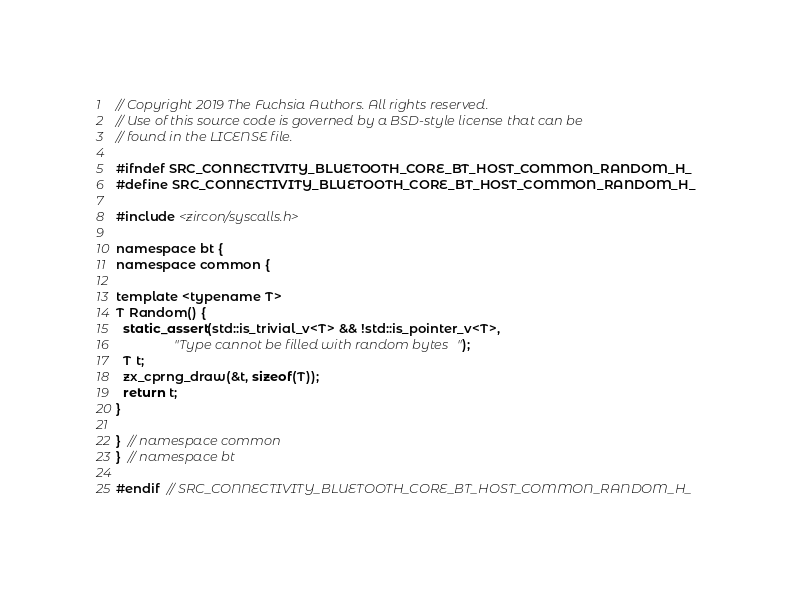<code> <loc_0><loc_0><loc_500><loc_500><_C_>// Copyright 2019 The Fuchsia Authors. All rights reserved.
// Use of this source code is governed by a BSD-style license that can be
// found in the LICENSE file.

#ifndef SRC_CONNECTIVITY_BLUETOOTH_CORE_BT_HOST_COMMON_RANDOM_H_
#define SRC_CONNECTIVITY_BLUETOOTH_CORE_BT_HOST_COMMON_RANDOM_H_

#include <zircon/syscalls.h>

namespace bt {
namespace common {

template <typename T>
T Random() {
  static_assert(std::is_trivial_v<T> && !std::is_pointer_v<T>,
                "Type cannot be filled with random bytes");
  T t;
  zx_cprng_draw(&t, sizeof(T));
  return t;
}

}  // namespace common
}  // namespace bt

#endif  // SRC_CONNECTIVITY_BLUETOOTH_CORE_BT_HOST_COMMON_RANDOM_H_
</code> 